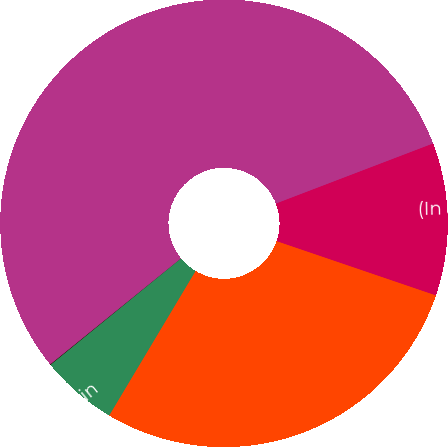Convert chart to OTSL. <chart><loc_0><loc_0><loc_500><loc_500><pie_chart><fcel>(In millions)<fcel>Net sales<fcel>Operating profit<fcel>Operating margin<fcel>Backlog at year-end<nl><fcel>11.04%<fcel>28.35%<fcel>5.54%<fcel>0.04%<fcel>55.04%<nl></chart> 